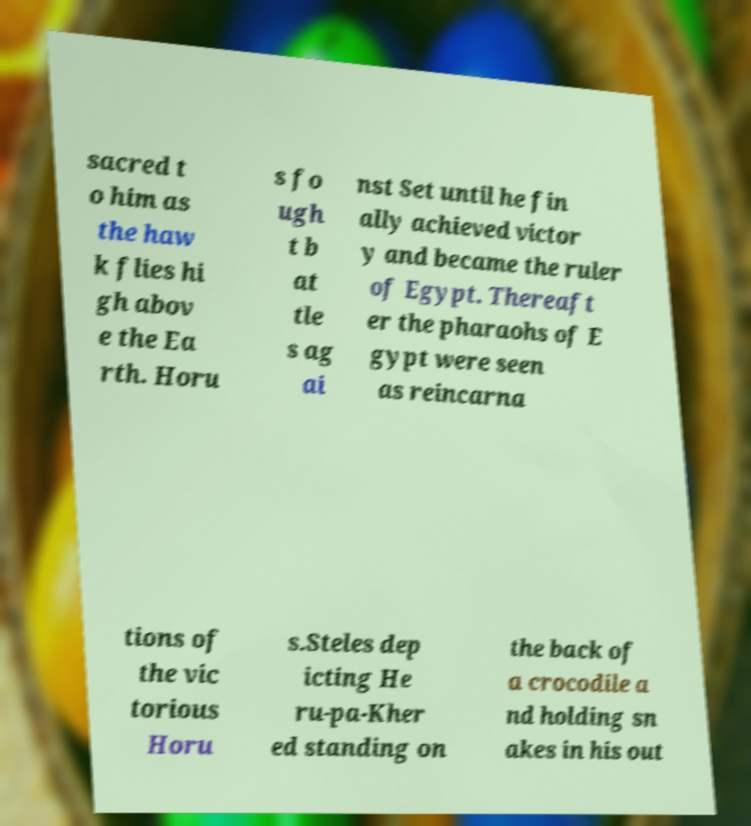There's text embedded in this image that I need extracted. Can you transcribe it verbatim? sacred t o him as the haw k flies hi gh abov e the Ea rth. Horu s fo ugh t b at tle s ag ai nst Set until he fin ally achieved victor y and became the ruler of Egypt. Thereaft er the pharaohs of E gypt were seen as reincarna tions of the vic torious Horu s.Steles dep icting He ru-pa-Kher ed standing on the back of a crocodile a nd holding sn akes in his out 